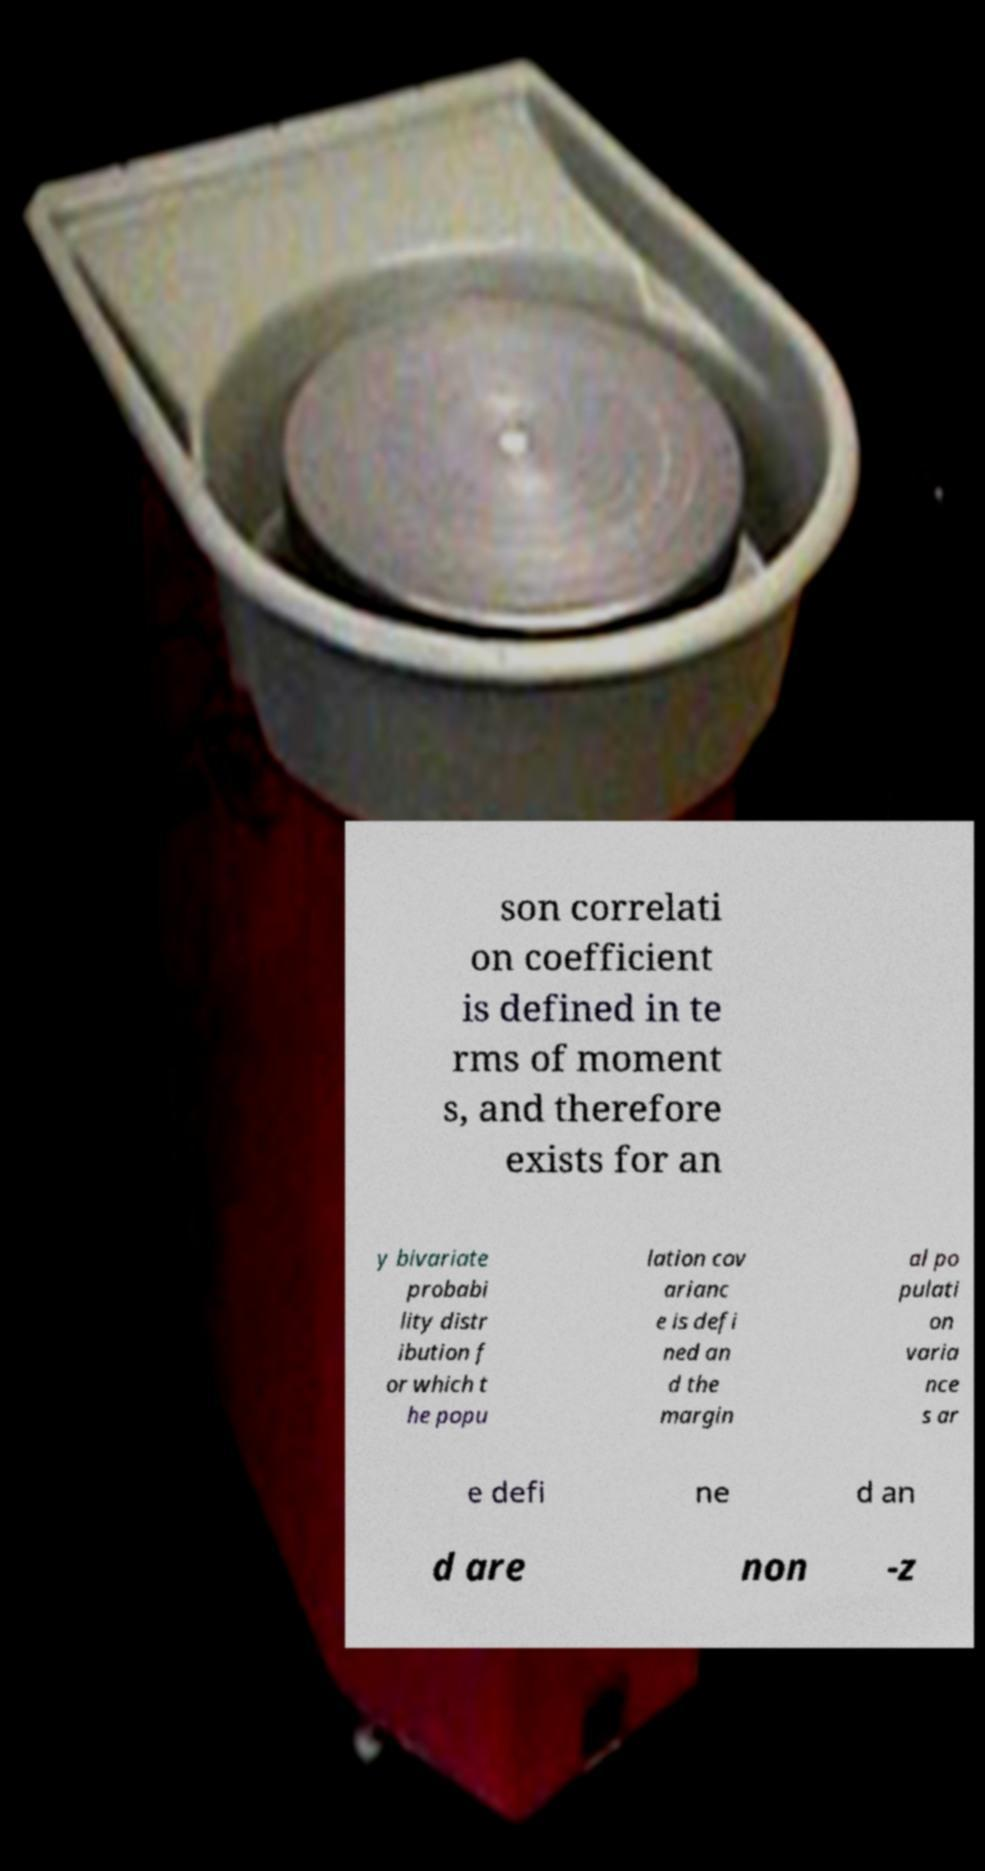Can you read and provide the text displayed in the image?This photo seems to have some interesting text. Can you extract and type it out for me? son correlati on coefficient is defined in te rms of moment s, and therefore exists for an y bivariate probabi lity distr ibution f or which t he popu lation cov arianc e is defi ned an d the margin al po pulati on varia nce s ar e defi ne d an d are non -z 